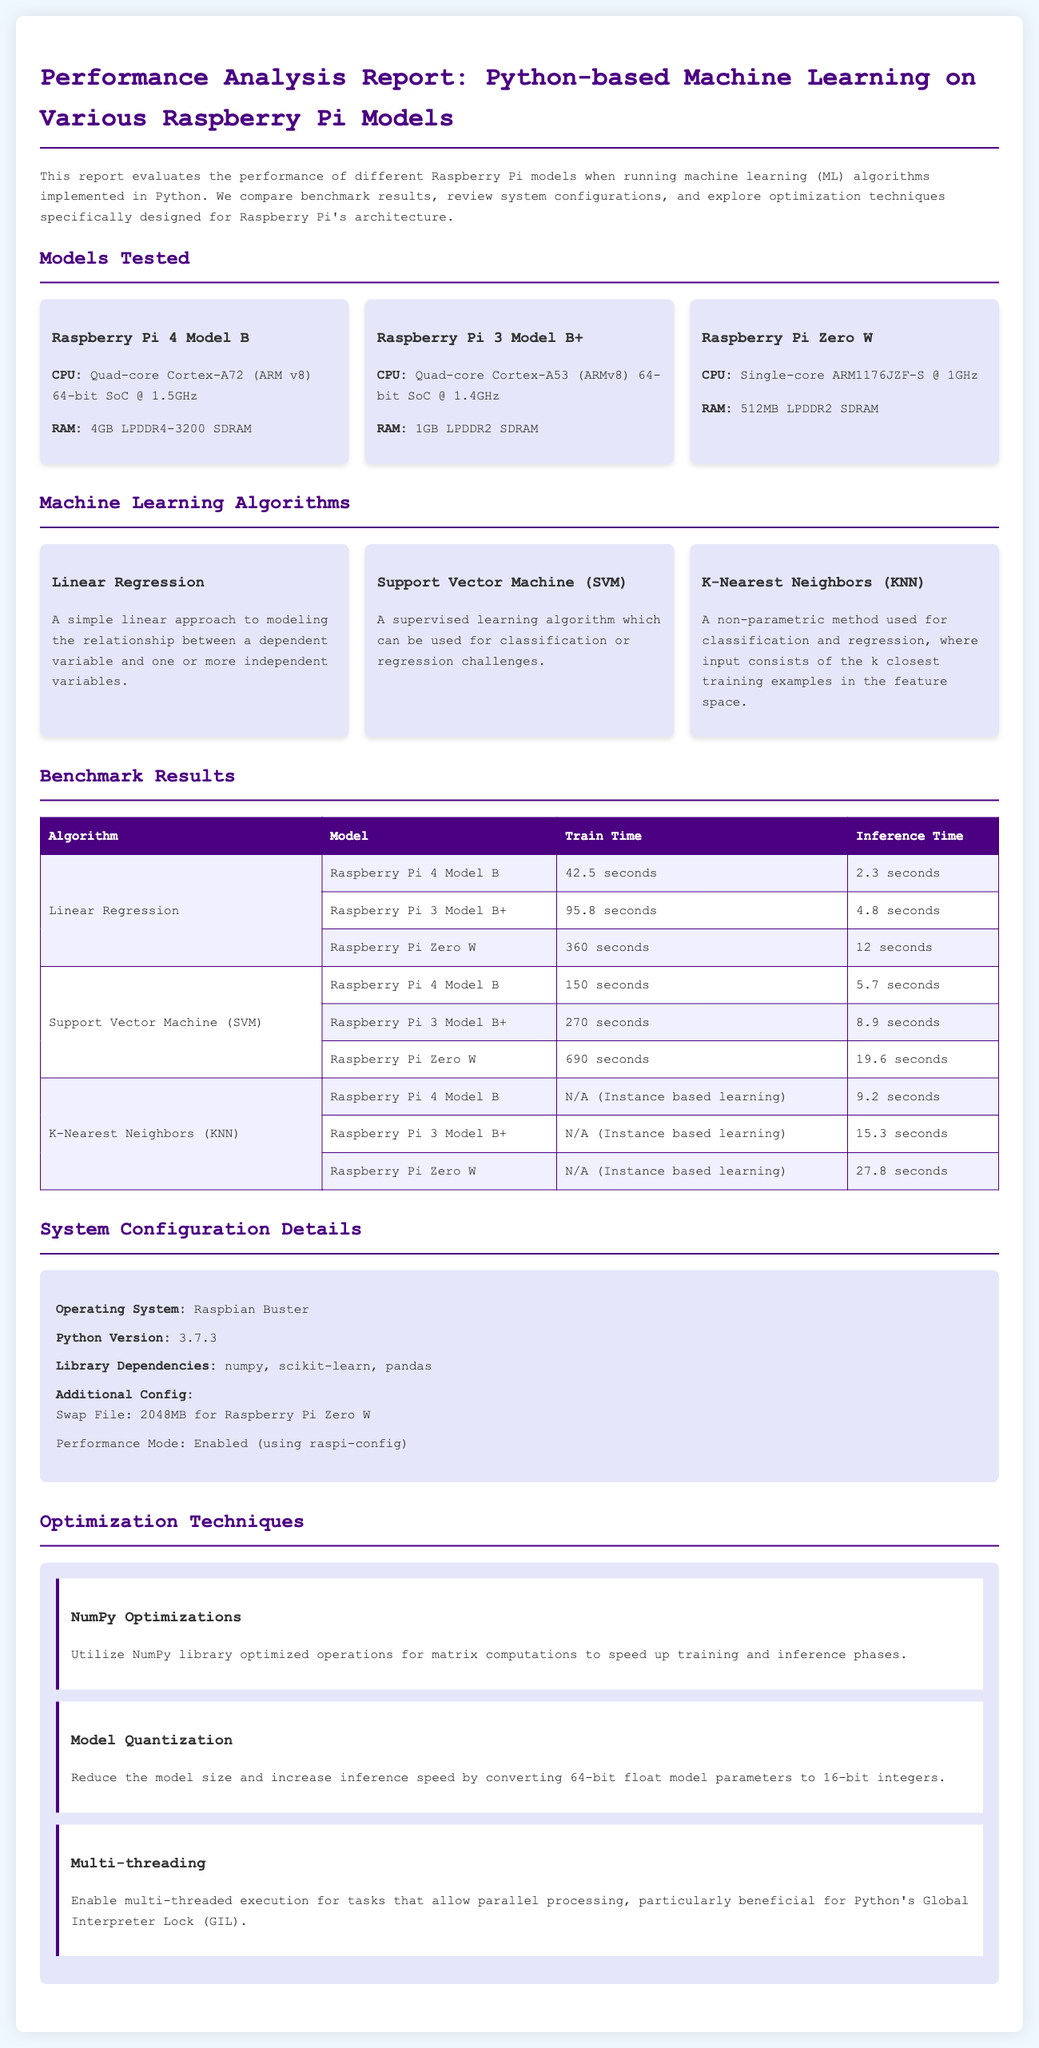What is the CPU of Raspberry Pi 4 Model B? The CPU of Raspberry Pi 4 Model B is a Quad-core Cortex-A72 (ARM v8) 64-bit SoC @ 1.5GHz.
Answer: Quad-core Cortex-A72 (ARM v8) 64-bit SoC @ 1.5GHz What is the inference time for K-Nearest Neighbors on Raspberry Pi Zero W? The inference time for K-Nearest Neighbors on Raspberry Pi Zero W is 27.8 seconds.
Answer: 27.8 seconds Which operating system was used in the tests? The operating system used in the tests is Raspbian Buster.
Answer: Raspbian Buster What optimization technique reduces the model size? The technique that reduces the model size is Model Quantization.
Answer: Model Quantization How long does it take to train the Support Vector Machine on Raspberry Pi 3 Model B+? The training time for Support Vector Machine on Raspberry Pi 3 Model B+ is 270 seconds.
Answer: 270 seconds What is the RAM of Raspberry Pi 3 Model B+? The RAM of Raspberry Pi 3 Model B+ is 1GB LPDDR2 SDRAM.
Answer: 1GB LPDDR2 SDRAM What Python version was used in the performance analysis? The Python version used is 3.7.3.
Answer: 3.7.3 What is the training time for Linear Regression on Raspberry Pi 4 Model B? The training time for Linear Regression on Raspberry Pi 4 Model B is 42.5 seconds.
Answer: 42.5 seconds Which algorithm's inference time is measured in the report? The algorithms whose inference time is measured are Linear Regression, Support Vector Machine (SVM), and K-Nearest Neighbors (KNN).
Answer: Linear Regression, Support Vector Machine (SVM), K-Nearest Neighbors (KNN) 